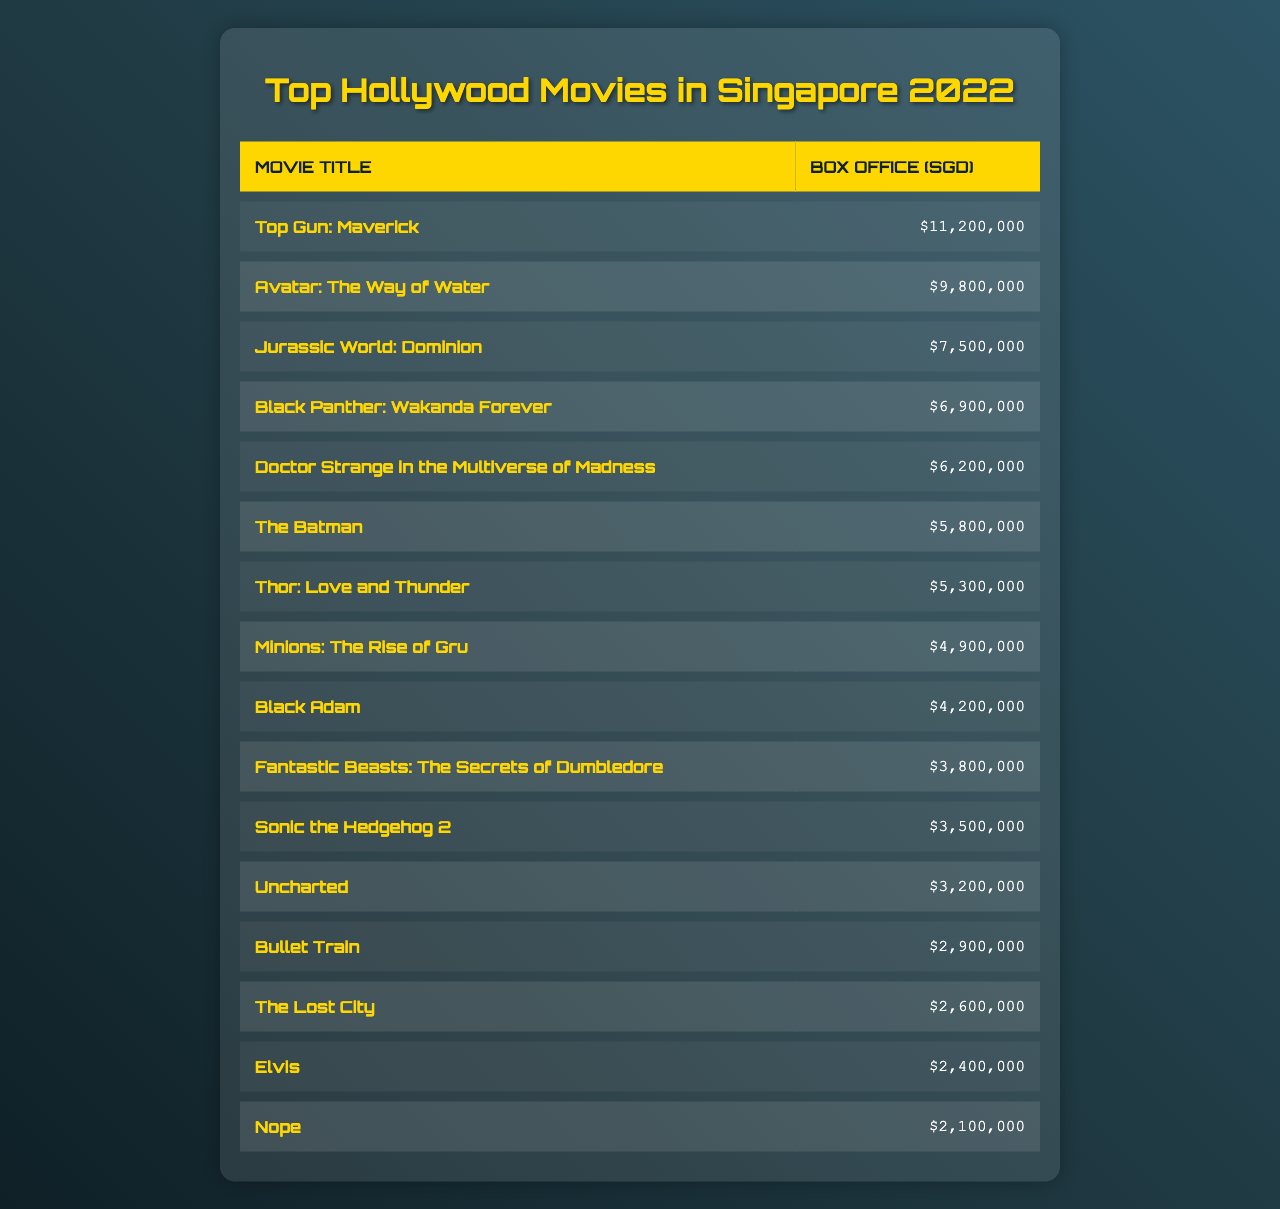What is the box office earning of "Top Gun: Maverick"? The table lists the box office earnings for each movie. For "Top Gun: Maverick," the earning is clearly stated as 11,200,000 SGD.
Answer: 11,200,000 Which movie earned more, "Avatar: The Way of Water" or "Jurassic World: Dominion"? According to the table, "Avatar: The Way of Water" earned 9,800,000 SGD, while "Jurassic World: Dominion" earned 7,500,000 SGD. Since 9,800,000 is greater than 7,500,000, "Avatar: The Way of Water" earned more.
Answer: Avatar: The Way of Water What is the total box office earning of the top three movies? The top three movies and their earnings are: "Top Gun: Maverick" (11,200,000), "Avatar: The Way of Water" (9,800,000), and "Jurassic World: Dominion" (7,500,000). Adding these gives 11,200,000 + 9,800,000 + 7,500,000 = 28,500,000 SGD.
Answer: 28,500,000 How much did "Black Panther: Wakanda Forever" earn compared to "Doctor Strange in the Multiverse of Madness"? "Black Panther: Wakanda Forever" earned 6,900,000 SGD and "Doctor Strange in the Multiverse of Madness" earned 6,200,000 SGD. The difference is 6,900,000 - 6,200,000 = 700,000 SGD, meaning "Black Panther" earned 700,000 more.
Answer: 700,000 Is the box office earning of "The Batman" greater than 6 million SGD? The table shows "The Batman" earned 5,800,000 SGD. Since 5,800,000 is less than 6,000,000, the statement is false.
Answer: No Which movie had the least earnings in the top 15? Looking through the earnings, "Nope" had the lowest at 2,100,000 SGD. This can be confirmed by comparing all earnings in the table.
Answer: Nope What is the average box office earning of the top 5 movies? The box office earnings of the top 5 movies are: 11,200,000 (Top Gun), 9,800,000 (Avatar), 7,500,000 (Jurassic), 6,900,000 (Black Panther), and 6,200,000 (Doctor Strange). Summing these gives 41,600,000, and dividing by 5 (41,600,000 / 5) yields an average of 8,320,000 SGD.
Answer: 8,320,000 If you combine the earnings of "Thor: Love and Thunder" and "Minions: The Rise of Gru," what would the total be? "Thor: Love and Thunder" earned 5,300,000 SGD and "Minions: The Rise of Gru" earned 4,900,000 SGD. Adding these earnings gives 5,300,000 + 4,900,000 = 10,200,000 SGD.
Answer: 10,200,000 Which two movies together exceeded 10 million SGD in box office earnings? Several combinations can be assessed, but starting with the highest, "Top Gun: Maverick" (11,200,000) alone exceeds 10 million. For combinations: "Avatar: The Way of Water" (9,800,000) and "Jurassic World: Dominion" (7,500,000) combined yield 17,300,000 SGD, which exceeds 10 million.
Answer: Top Gun: Maverick, Avatar: The Way of Water Is "Fantastic Beasts: The Secrets of Dumbledore" among the top five earners? The table ranks the earnings, and "Fantastic Beasts" is listed with a box office of 3,800,000 SGD, which is below the top five listed earnings. Therefore, it is not among the top five earners.
Answer: No 